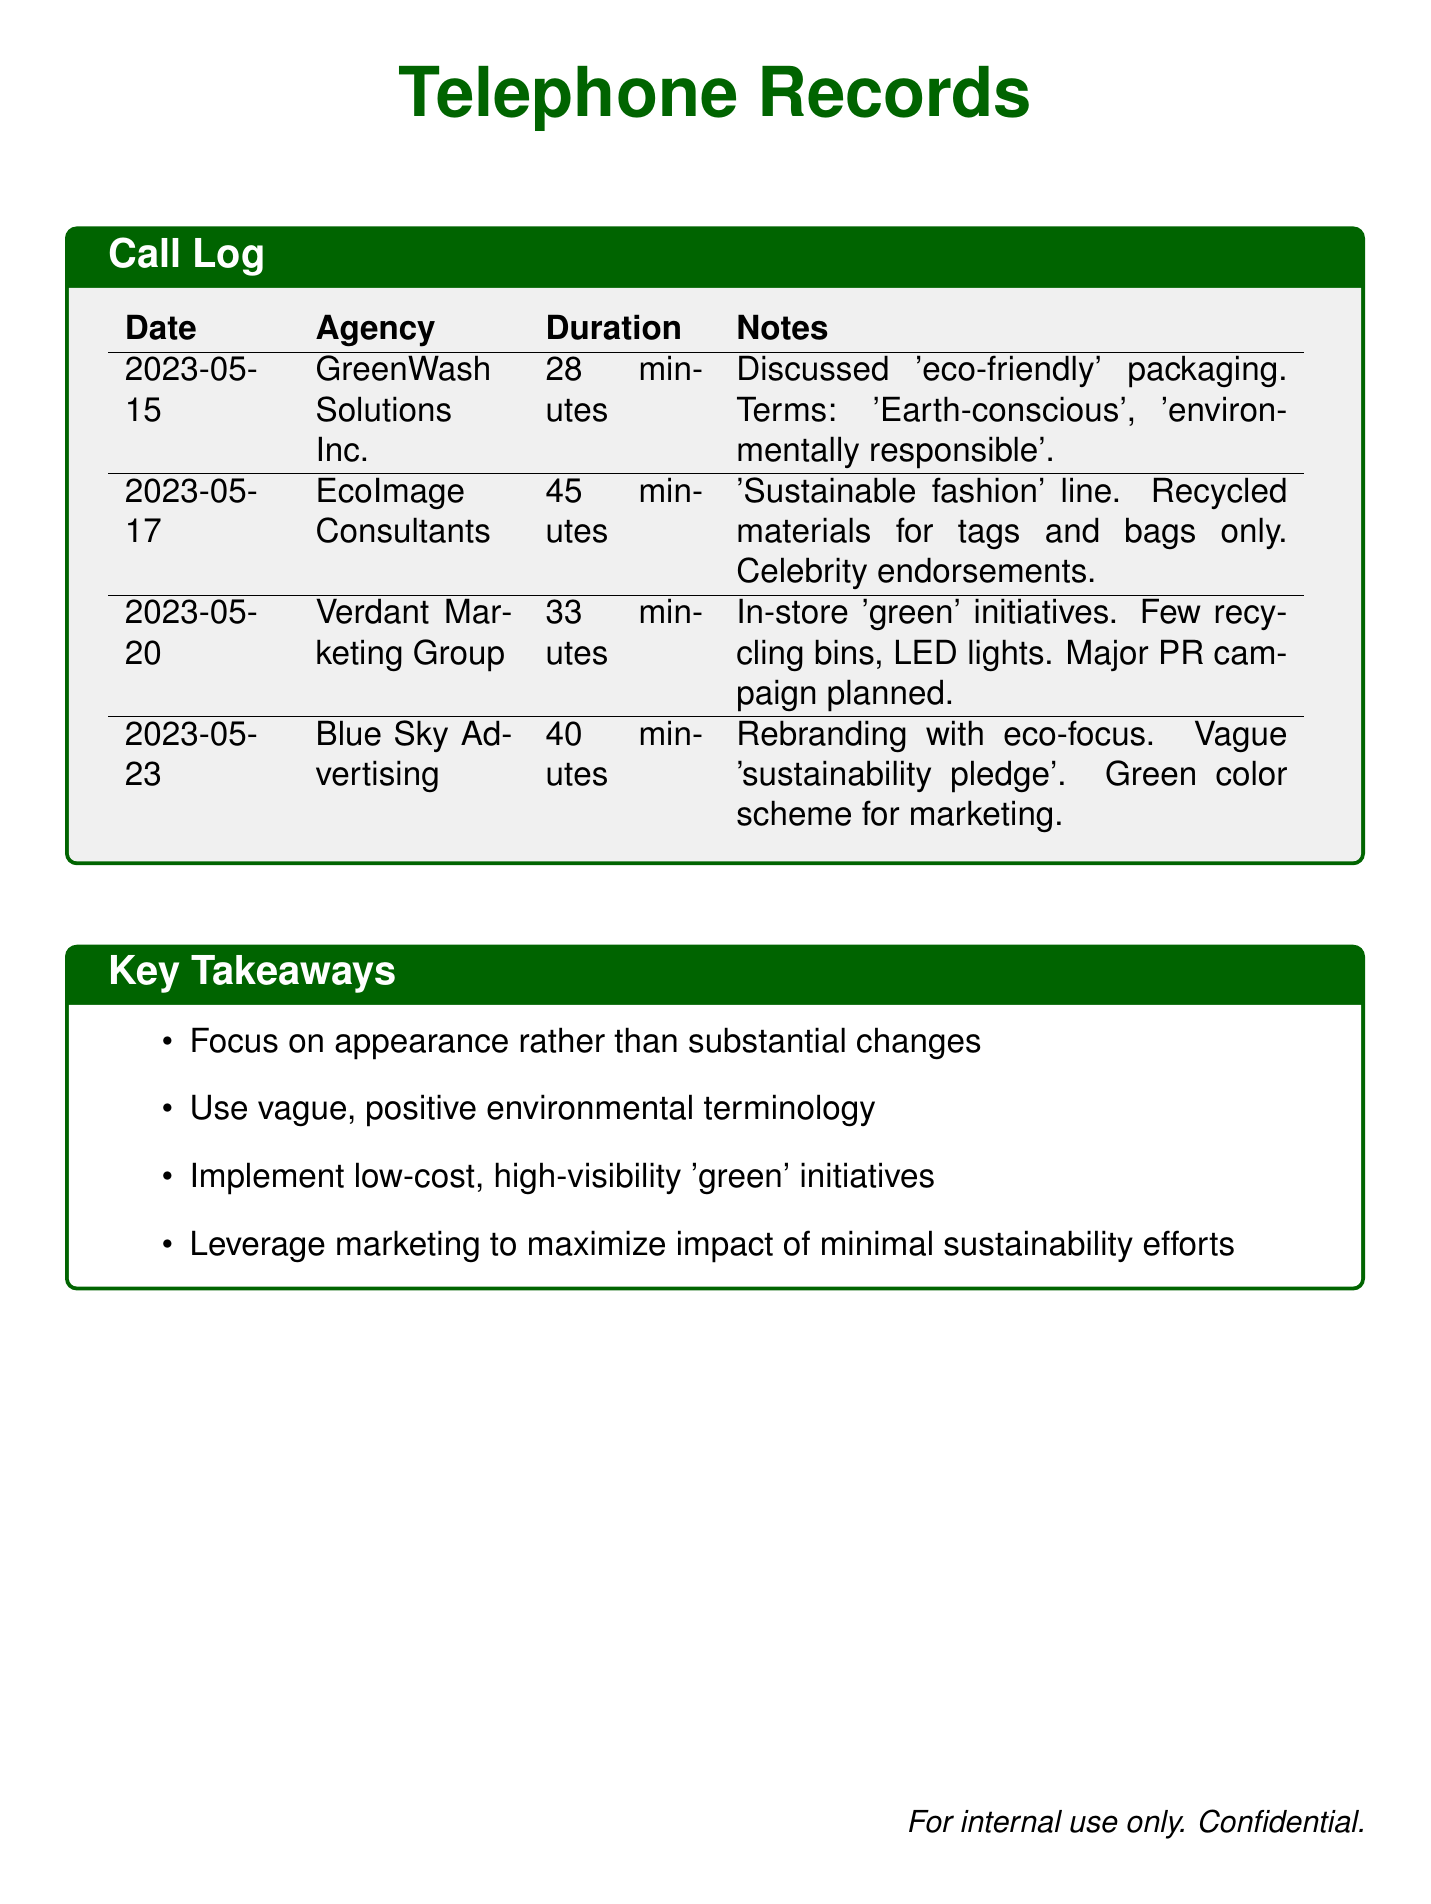What is the date of the first call? The first call in the log was made on May 15, 2023.
Answer: May 15, 2023 Which agency was involved in the call on May 20? The agency for the call on May 20 is Verdant Marketing Group.
Answer: Verdant Marketing Group How long was the call with EcoImage Consultants? The duration of the call with EcoImage Consultants is explicitly provided as 45 minutes.
Answer: 45 minutes What was discussed during the call with GreenWash Solutions Inc.? The notes indicate that 'eco-friendly' packaging was discussed during the call.
Answer: 'eco-friendly' packaging How many calls are documented in total? The document lists a total of four calls made to different marketing agencies.
Answer: Four What type of initiatives did Verdant Marketing Group plan? The notes mention 'in-store green initiatives' were discussed during the call with Verdant Marketing Group.
Answer: In-store 'green' initiatives What is a major focus indicated in the Key Takeaways? The Key Takeaways highlight that a major focus is on appearance rather than substantial changes.
Answer: Appearance rather than substantial changes What was the proposed marketing strategy for the call with Blue Sky Advertising? The proposed strategy involved rebranding with an eco-focus and a vague 'sustainability pledge'.
Answer: Rebranding with eco-focus 